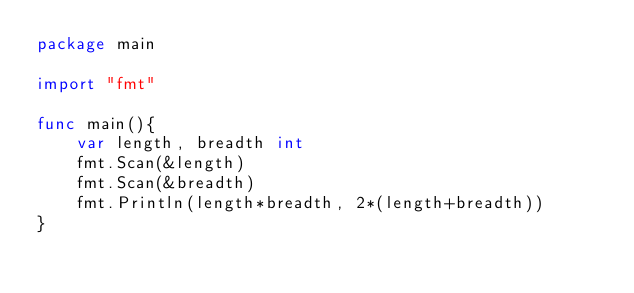Convert code to text. <code><loc_0><loc_0><loc_500><loc_500><_Go_>package main

import "fmt"

func main(){
    var length, breadth int
    fmt.Scan(&length)
    fmt.Scan(&breadth)
    fmt.Println(length*breadth, 2*(length+breadth))
}
</code> 